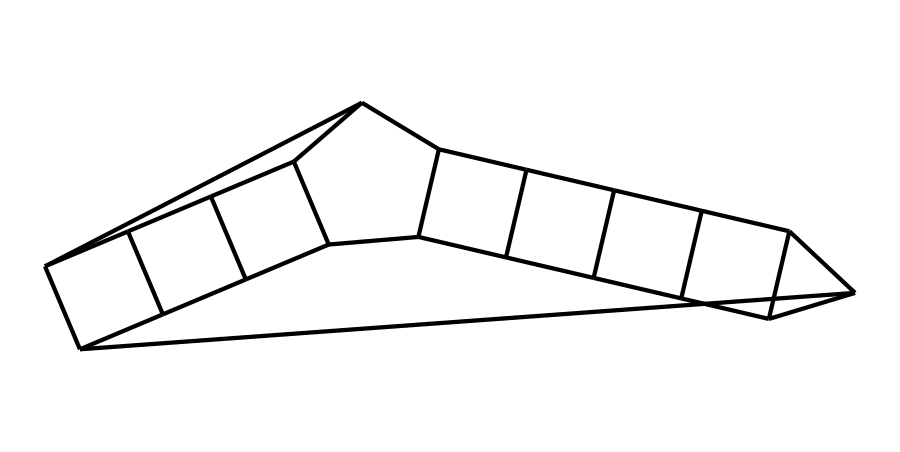how many carbon atoms are in dodecahedrane? By examining the SMILES representation, we can identify that dodecahedrane is composed of a specific arrangement of carbon atoms. The structure represents a polyhedral arrangement with a total of 20 carbon atoms.
Answer: 20 what type of geometric shape does dodecahedrane represent? The SMILES notation indicates that the molecular structure is a cage-like compound featuring symmetrical arrangements typical of fullerene structures. In this case, it specifically forms a dodecahedron, which has 12 faces.
Answer: dodecahedron how many hydrogen atoms are bonded to each carbon in dodecahedrane? Given that dodecahedrane is a saturated hydrocarbon, each carbon in the structure can form four bonds. Since all carbons are bonded to other carbons, the remaining valences typically bond with hydrogen atoms. Analyzing the structure, we find that this leads to 20 hydrogen atoms bonded to the 20 carbons, resulting in a 1:1 ratio of carbon to hydrogen.
Answer: 2 what distinguishes cage compounds like dodecahedrane from other hydrocarbons? Cage compounds are characterized by their unique molecular geometry that creates a "cage" structure, unlike linear or branched hydrocarbons. In dodecahedrane, the arrangement of carbon atoms allows for a three-dimensional shape that encloses a volume, unlike most simple hydrocarbons that are chains or branched. This structural uniqueness is a defining feature of cage compounds.
Answer: unique geometry how does the structure of dodecahedrane affect its stability? The dodecahedron shape contributes to specific characteristic stability in cage compounds, as the tetrahedral bonding angles around the sp3 hybridized carbons provide a strain-free environment. Thus, the even distribution of carbon-carbon bonds and the solid framework support the compound's high stability compared to other forms of hydrocarbons, which may have more strained or reactive geometries.
Answer: high stability 